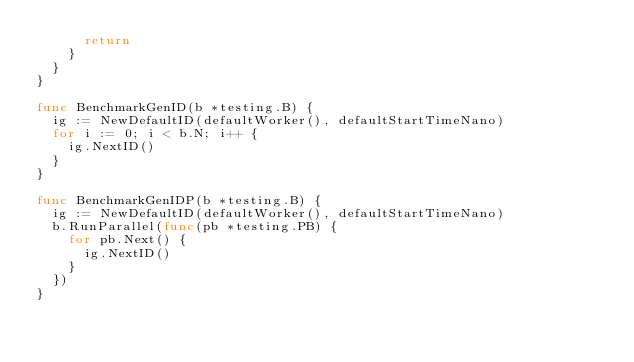<code> <loc_0><loc_0><loc_500><loc_500><_Go_>			return
		}
	}
}

func BenchmarkGenID(b *testing.B) {
	ig := NewDefaultID(defaultWorker(), defaultStartTimeNano)
	for i := 0; i < b.N; i++ {
		ig.NextID()
	}
}

func BenchmarkGenIDP(b *testing.B) {
	ig := NewDefaultID(defaultWorker(), defaultStartTimeNano)
	b.RunParallel(func(pb *testing.PB) {
		for pb.Next() {
			ig.NextID()
		}
	})
}
</code> 